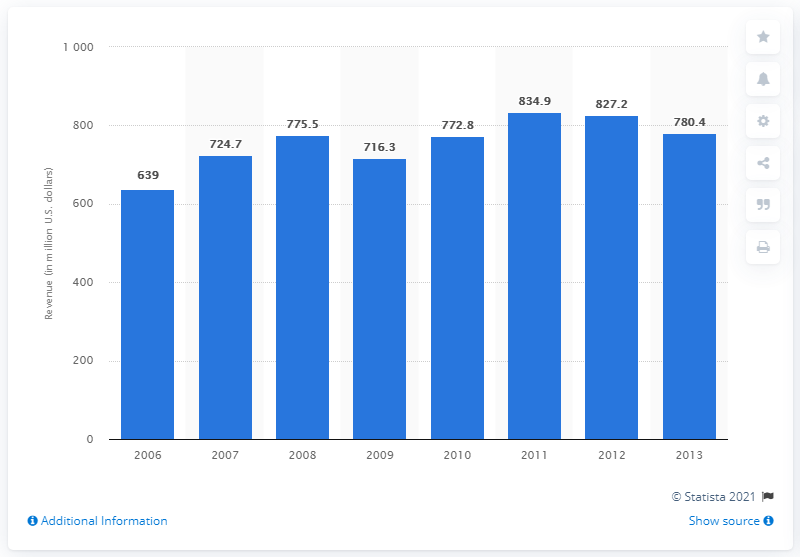Point out several critical features in this image. Easton-Bell Sports generated approximately $639 million in revenue in 2006. 